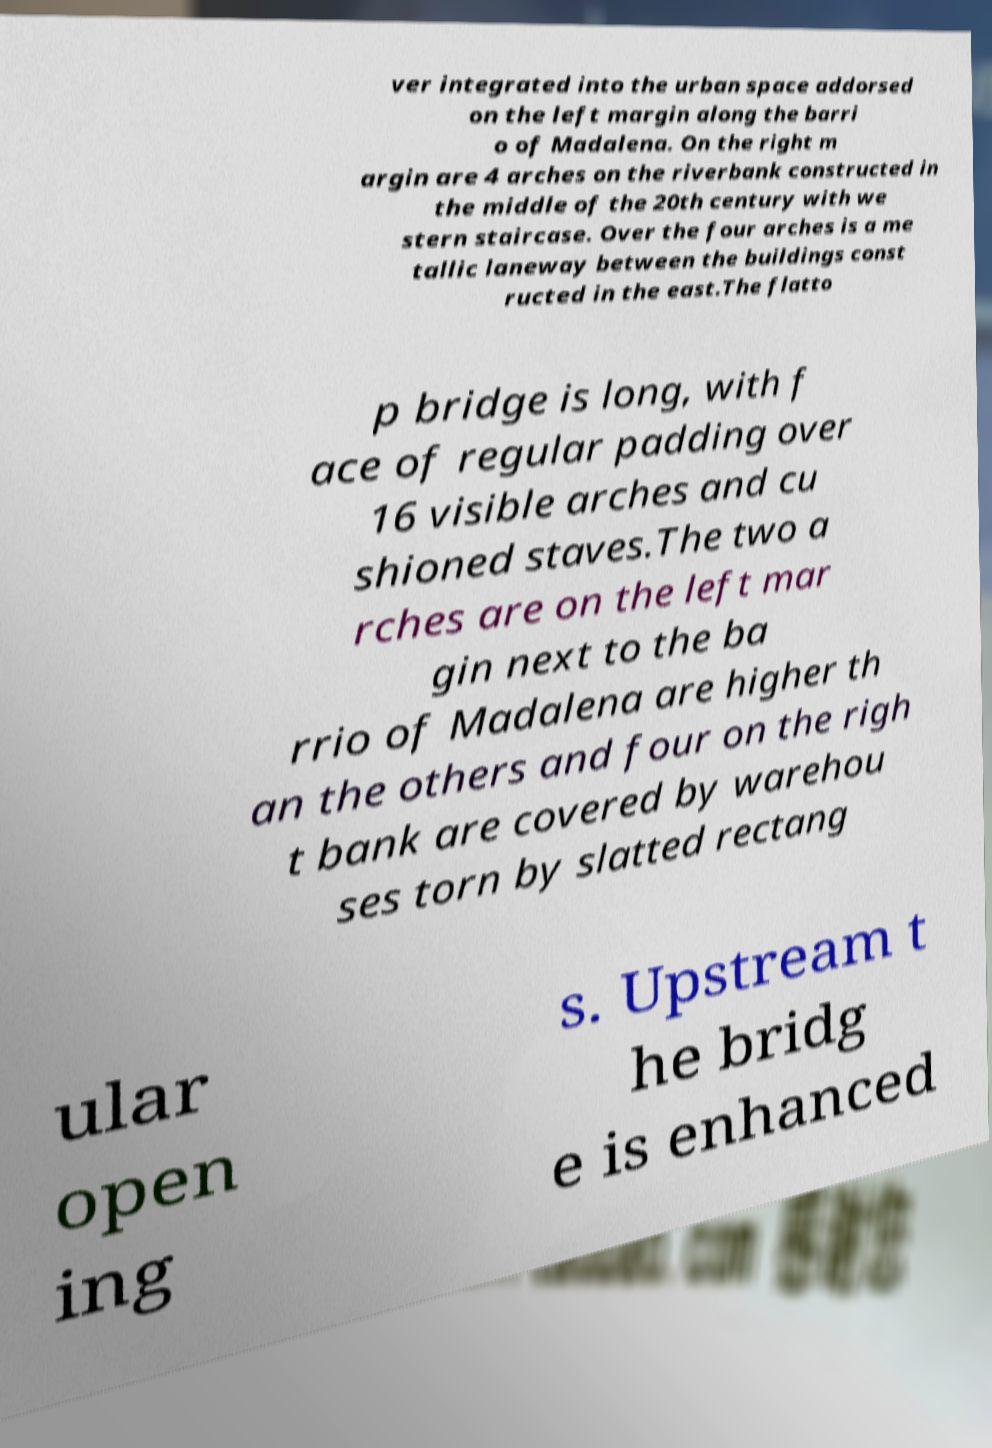What messages or text are displayed in this image? I need them in a readable, typed format. ver integrated into the urban space addorsed on the left margin along the barri o of Madalena. On the right m argin are 4 arches on the riverbank constructed in the middle of the 20th century with we stern staircase. Over the four arches is a me tallic laneway between the buildings const ructed in the east.The flatto p bridge is long, with f ace of regular padding over 16 visible arches and cu shioned staves.The two a rches are on the left mar gin next to the ba rrio of Madalena are higher th an the others and four on the righ t bank are covered by warehou ses torn by slatted rectang ular open ing s. Upstream t he bridg e is enhanced 